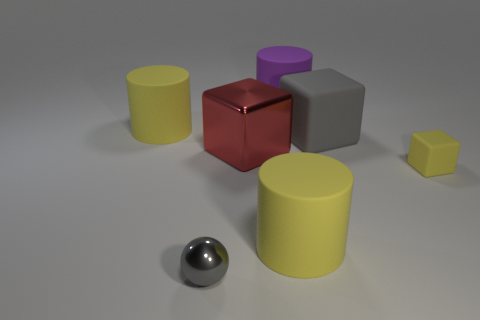How big is the gray metallic object?
Give a very brief answer. Small. How many other large red objects are the same shape as the big red metallic object?
Your answer should be compact. 0. Does the metal block have the same color as the tiny metallic object?
Your answer should be compact. No. The big gray cube on the right side of the metal object that is left of the big block that is to the left of the purple thing is made of what material?
Your answer should be compact. Rubber. There is a large red block; are there any purple objects behind it?
Make the answer very short. Yes. What is the shape of the gray rubber thing that is the same size as the purple thing?
Offer a terse response. Cube. Is the large red block made of the same material as the small yellow block?
Provide a succinct answer. No. What number of matte objects are either yellow cylinders or red things?
Provide a short and direct response. 2. The rubber thing that is the same color as the metallic ball is what shape?
Offer a very short reply. Cube. Do the thing left of the small metal sphere and the tiny ball have the same color?
Provide a succinct answer. No. 